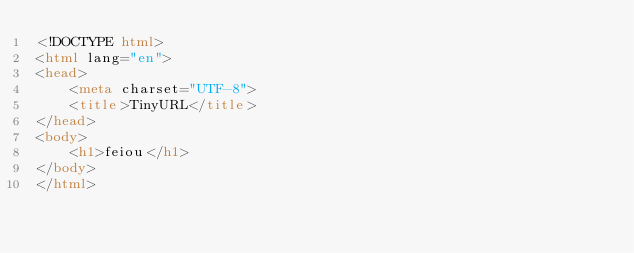<code> <loc_0><loc_0><loc_500><loc_500><_HTML_><!DOCTYPE html>
<html lang="en">
<head>
    <meta charset="UTF-8">
    <title>TinyURL</title>
</head>
<body>
    <h1>feiou</h1>
</body>
</html></code> 